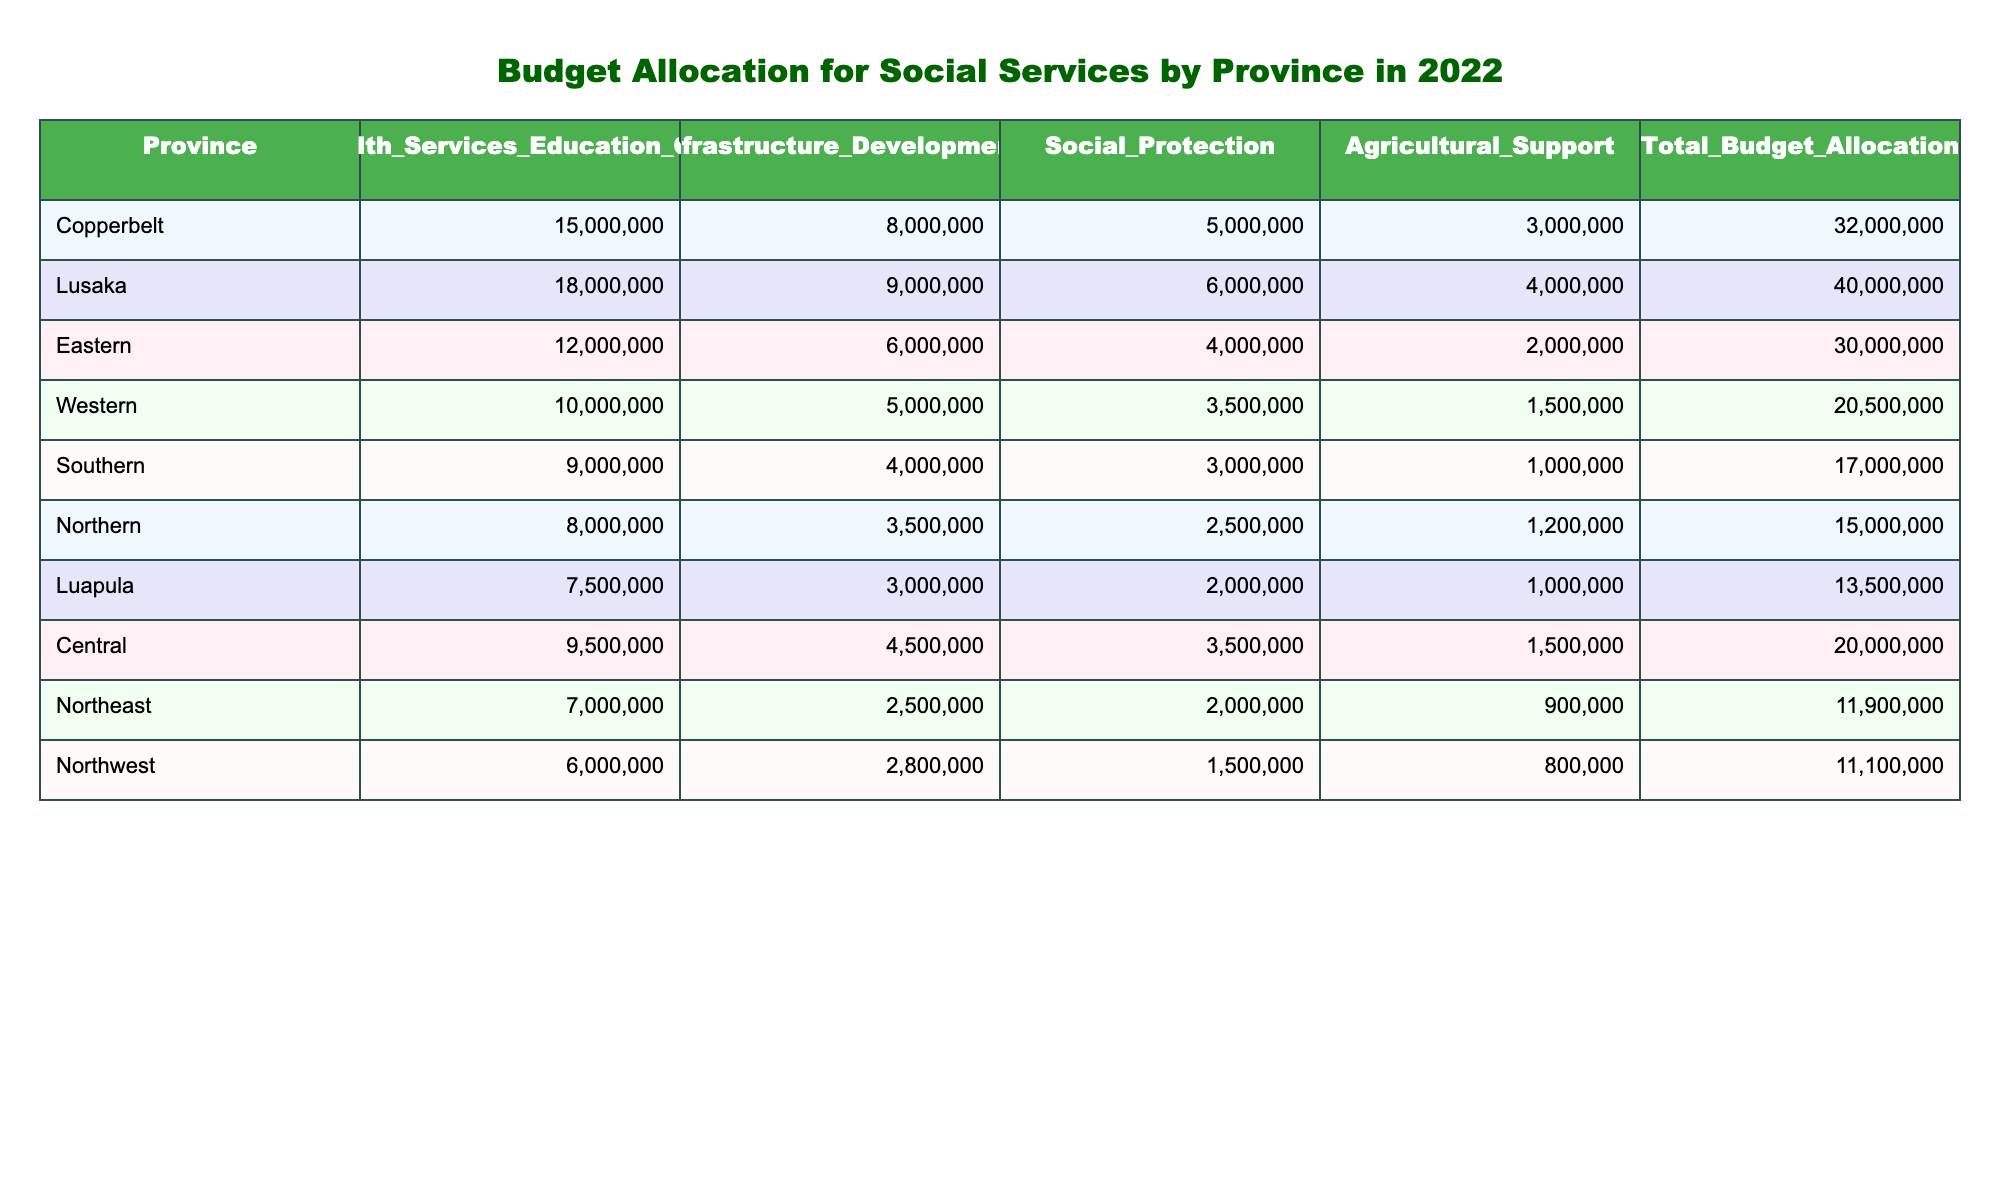What is the total budget allocation for Lusaka? The total budget allocation for Lusaka is directly provided in the table under the "Total_Budget_Allocation" column, which lists the value as 40000000.
Answer: 40000000 What province has the highest budget allocation for Health Services? The table lists the budget allocation for Health Services by province. By comparing the values, Lusaka has the highest allocation at 18000000.
Answer: 18000000 Is the budget allocation for Social Protection in the Copperbelt province higher than that in the Southern province? The values for Social Protection are 5000000 for Copperbelt and 3000000 for Southern province. Since 5000000 is greater than 3000000, the statement is true.
Answer: Yes What is the average budget allocation for Infrastructure Development across all provinces? The budget allocations for Infrastructure Development are 8000000, 9000000, 6000000, 5000000, 4000000, 3500000, 3000000, 4500000, 2500000, and 2800000 respectively. Summing these values gives 42500000, and dividing by the number of provinces (10) yields an average of 4250000.
Answer: 4250000 Which province received the least allocation for Agricultural Support? The table indicates that the province with the least allocation for Agricultural Support is Northeast, with an allocation of 900000.
Answer: Northeast How much higher is the total budget allocation of Eastern compared to Luapula? The total budget allocation for Eastern is 30000000 and for Luapula is 13500000. The difference is calculated by subtracting Luapula's allocation from Eastern's, resulting in 30000000 - 13500000 = 16500000.
Answer: 16500000 Is Southern province's budget allocation equal to that of Western province? Southern's total budget allocation is 17000000, while Western's is 20500000. Since these two values are different, the statement is false.
Answer: No What is the total budget allocation for social services in the Northern and Central provinces combined? The total budget allocation for Northern is 15000000 and for Central is 20000000. Adding these amounts gives 15000000 + 20000000 = 35000000.
Answer: 35000000 